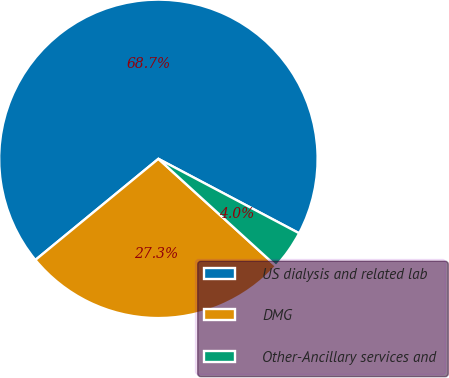Convert chart to OTSL. <chart><loc_0><loc_0><loc_500><loc_500><pie_chart><fcel>US dialysis and related lab<fcel>DMG<fcel>Other-Ancillary services and<nl><fcel>68.69%<fcel>27.29%<fcel>4.02%<nl></chart> 